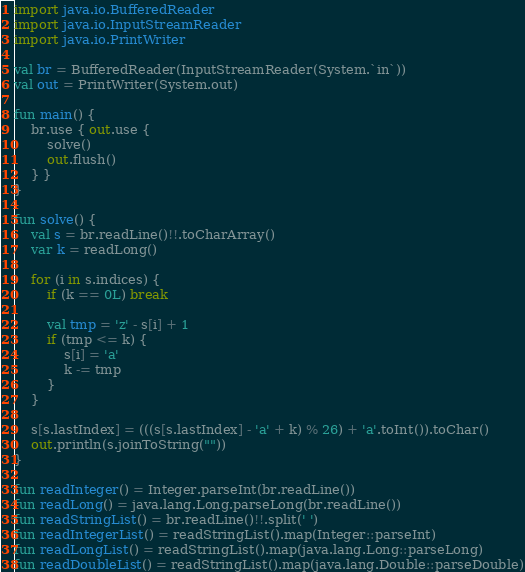Convert code to text. <code><loc_0><loc_0><loc_500><loc_500><_Kotlin_>import java.io.BufferedReader
import java.io.InputStreamReader
import java.io.PrintWriter

val br = BufferedReader(InputStreamReader(System.`in`))
val out = PrintWriter(System.out)

fun main() {
    br.use { out.use {
        solve()
        out.flush()
    } }
}

fun solve() {
    val s = br.readLine()!!.toCharArray()
    var k = readLong()

    for (i in s.indices) {
        if (k == 0L) break

        val tmp = 'z' - s[i] + 1
        if (tmp <= k) {
            s[i] = 'a'
            k -= tmp
        }
    }

    s[s.lastIndex] = (((s[s.lastIndex] - 'a' + k) % 26) + 'a'.toInt()).toChar()
    out.println(s.joinToString(""))
}

fun readInteger() = Integer.parseInt(br.readLine())
fun readLong() = java.lang.Long.parseLong(br.readLine())
fun readStringList() = br.readLine()!!.split(' ')
fun readIntegerList() = readStringList().map(Integer::parseInt)
fun readLongList() = readStringList().map(java.lang.Long::parseLong)
fun readDoubleList() = readStringList().map(java.lang.Double::parseDouble)
</code> 